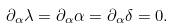Convert formula to latex. <formula><loc_0><loc_0><loc_500><loc_500>\partial _ { \alpha } \lambda = \partial _ { \alpha } \alpha = \partial _ { \alpha } \delta = 0 .</formula> 